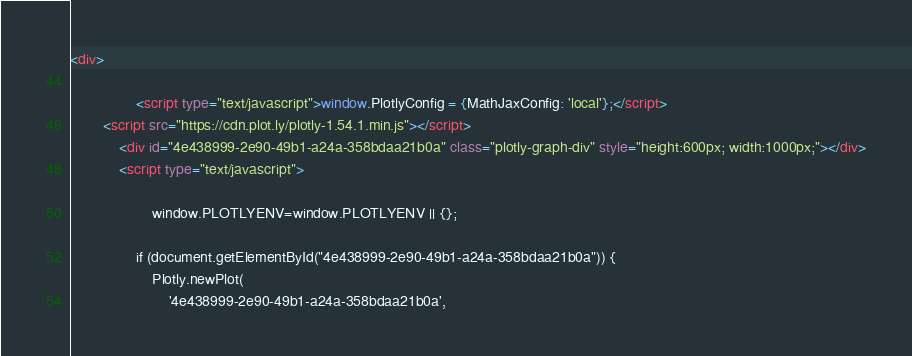<code> <loc_0><loc_0><loc_500><loc_500><_HTML_><div>
        
                <script type="text/javascript">window.PlotlyConfig = {MathJaxConfig: 'local'};</script>
        <script src="https://cdn.plot.ly/plotly-1.54.1.min.js"></script>    
            <div id="4e438999-2e90-49b1-a24a-358bdaa21b0a" class="plotly-graph-div" style="height:600px; width:1000px;"></div>
            <script type="text/javascript">
                
                    window.PLOTLYENV=window.PLOTLYENV || {};
                    
                if (document.getElementById("4e438999-2e90-49b1-a24a-358bdaa21b0a")) {
                    Plotly.newPlot(
                        '4e438999-2e90-49b1-a24a-358bdaa21b0a',</code> 